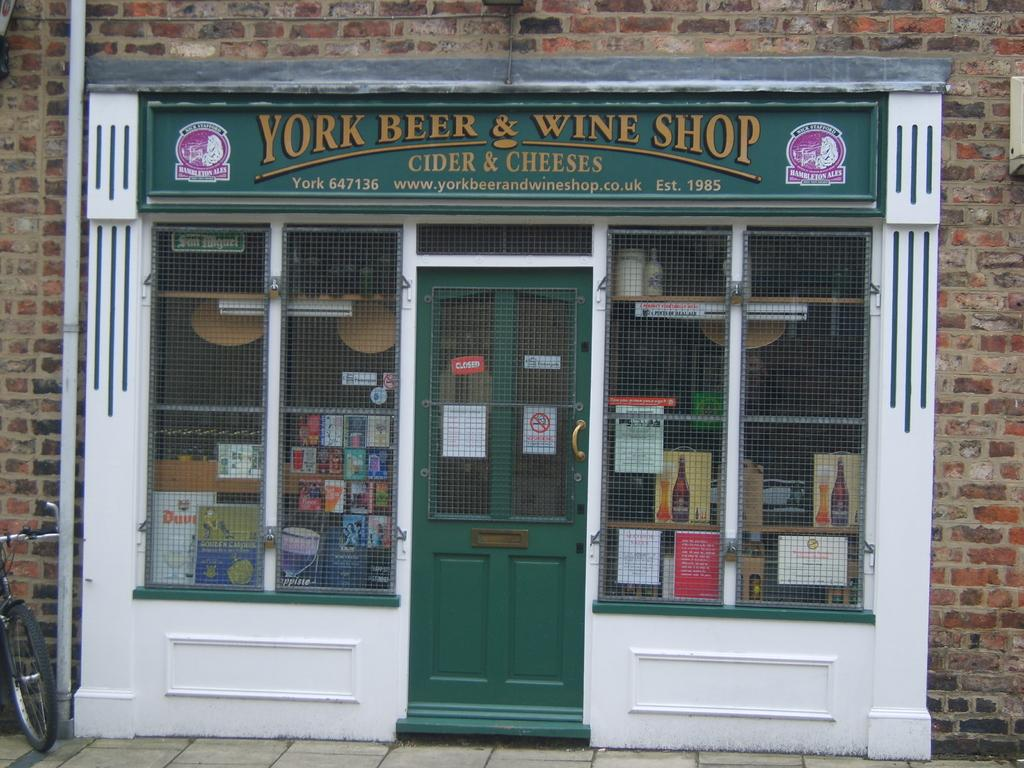What type of establishment is shown in the image? The image depicts a shop. How can the name of the shop be identified? There is a name board on the wall of the shop. What are the main access points to the shop? There are doors in the shop. What items can be seen inside the shop? There are boxes in the shop. What is used to illuminate the interior of the shop? There are lights in the shop. What is attached to the wall of the shop? There is a pipe on the wall of the shop. What is located on the floor of the shop? There is a bicycle on the floor of the shop. What is visible in the background of the image? There is a wall visible in the image. What type of veil is draped over the bicycle in the image? There is no veil present in the image; it only shows a bicycle on the floor of the shop. Is there a maid in the image assisting customers? There is no maid present in the image; it only shows a shop with various items and a bicycle on the floor. 